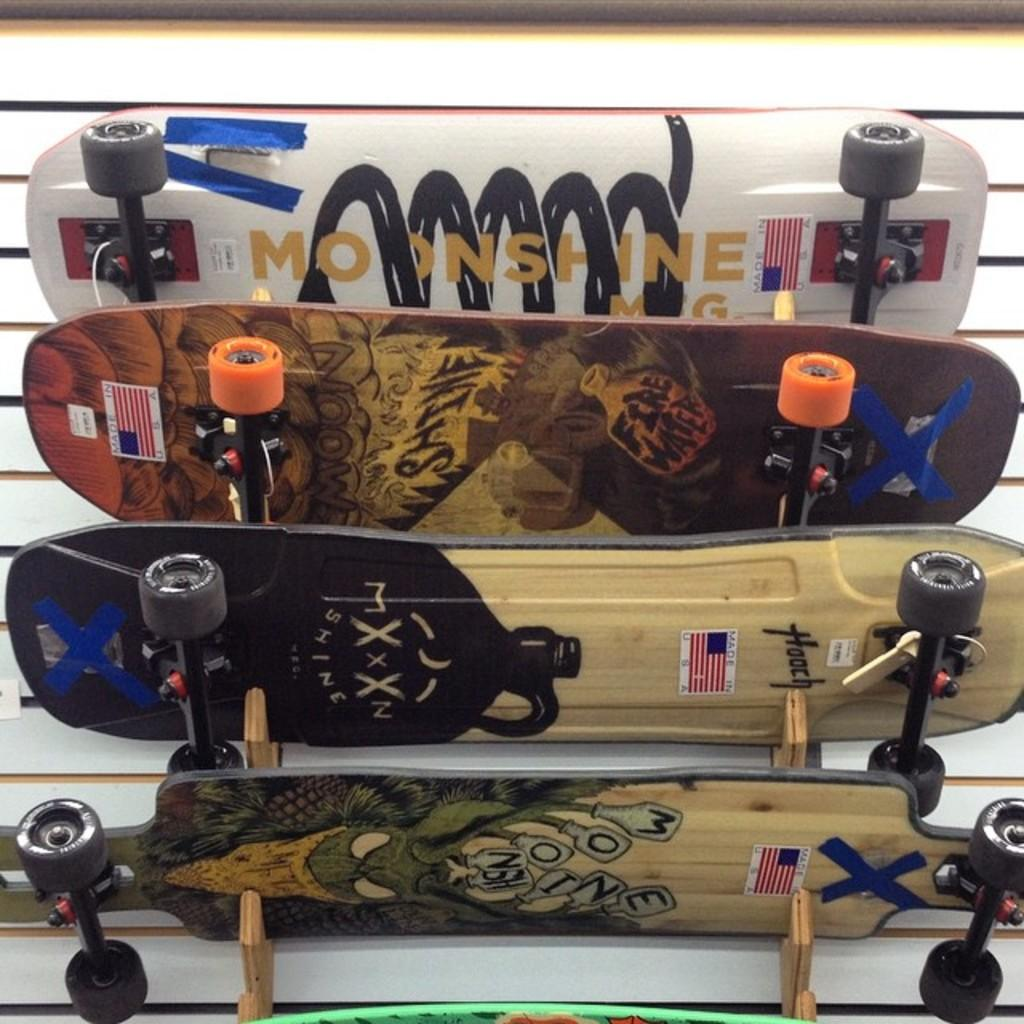How many skateboards are visible in the image? There are four skateboards in the image. What color are the skateboards? The skateboards are white in color. What type of cheese is being used as a cushion for the duck in the image? There is no duck or cheese present in the image; it only features four white skateboards. 